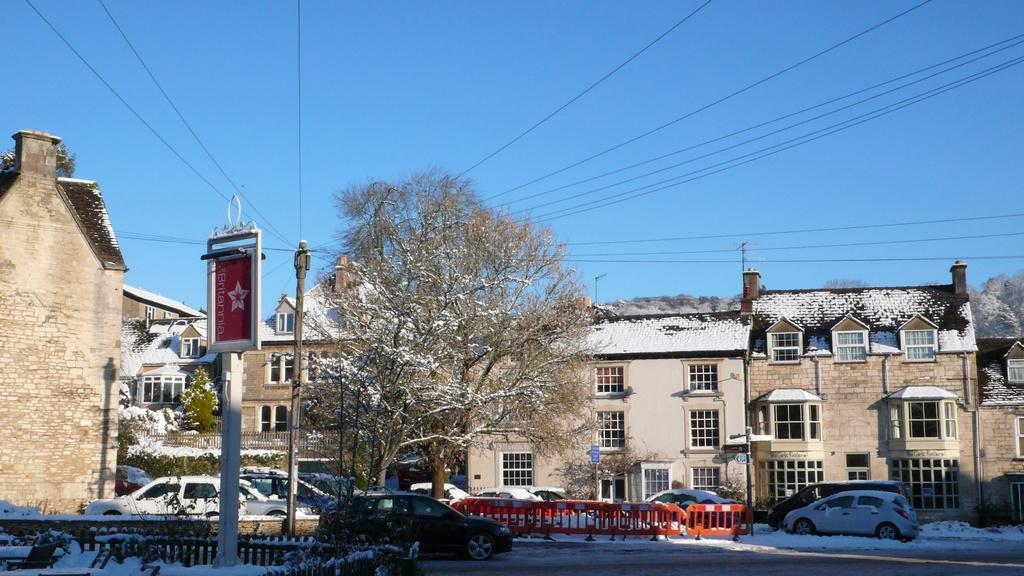What can be seen on the road in the image? There are vehicles on the road in the image. How are the vehicles affected by the weather in the image? The vehicles are covered with snow in the image. What can be seen in the background of the image? There are houses, trees, poles, and wires visible in the background of the image. How is the snow affecting the background elements in the image? All elements mentioned, including the houses, trees, poles, and wires, are covered with snow in the image. What type of plant can be seen growing near the seashore in the image? There is no seashore present in the image, and therefore no plant growing near it. 